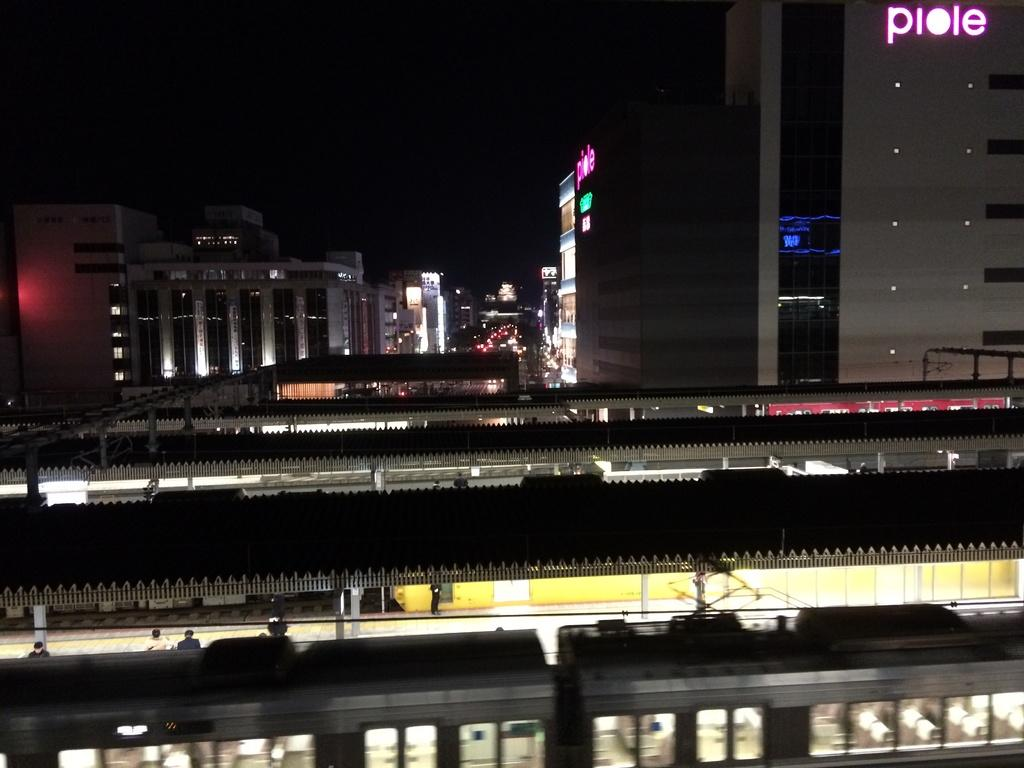What is the main subject of the image? The main subject of the image is a train. What else can be seen in the image besides the train? There are shelters, buildings, lights, objects, and people in the image. Can you describe the lighting in the image? There are lights visible in the image. How many people can be seen in the image? There are people in the image. What is the color of the background in the image? The background of the image is dark. Where is the scarecrow located in the image? There is no scarecrow present in the image. What idea does the image represent? The image does not represent a specific idea; it is a visual representation of a train and its surroundings. 